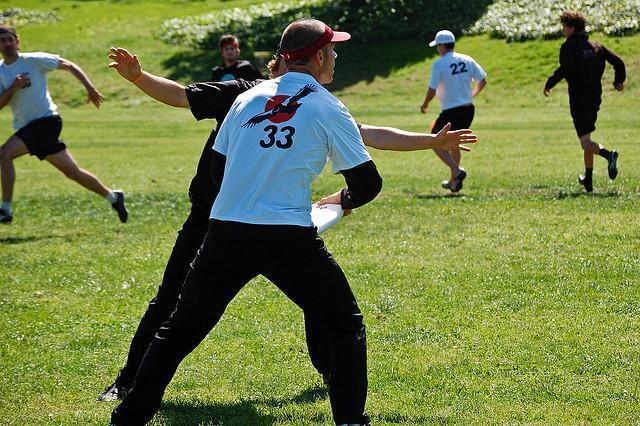How many men are wearing white shirts?
Give a very brief answer. 3. How many people are in the picture?
Give a very brief answer. 5. 